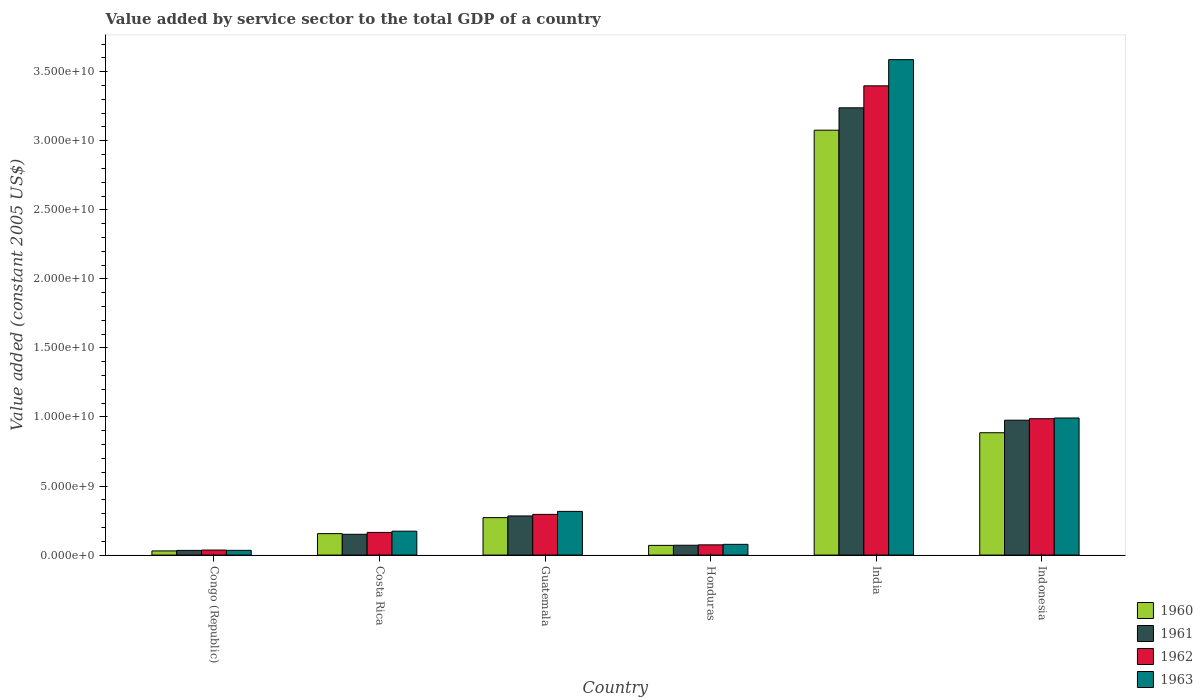How many groups of bars are there?
Offer a very short reply. 6. Are the number of bars per tick equal to the number of legend labels?
Ensure brevity in your answer.  Yes. Are the number of bars on each tick of the X-axis equal?
Your answer should be very brief. Yes. How many bars are there on the 4th tick from the right?
Offer a very short reply. 4. In how many cases, is the number of bars for a given country not equal to the number of legend labels?
Provide a succinct answer. 0. What is the value added by service sector in 1961 in Congo (Republic)?
Offer a very short reply. 3.39e+08. Across all countries, what is the maximum value added by service sector in 1960?
Ensure brevity in your answer.  3.08e+1. Across all countries, what is the minimum value added by service sector in 1963?
Your answer should be very brief. 3.42e+08. In which country was the value added by service sector in 1963 minimum?
Make the answer very short. Congo (Republic). What is the total value added by service sector in 1961 in the graph?
Provide a succinct answer. 4.75e+1. What is the difference between the value added by service sector in 1963 in Guatemala and that in Honduras?
Provide a succinct answer. 2.39e+09. What is the difference between the value added by service sector in 1961 in Honduras and the value added by service sector in 1962 in India?
Provide a succinct answer. -3.33e+1. What is the average value added by service sector in 1963 per country?
Provide a succinct answer. 8.64e+09. What is the difference between the value added by service sector of/in 1960 and value added by service sector of/in 1963 in Indonesia?
Your response must be concise. -1.07e+09. In how many countries, is the value added by service sector in 1963 greater than 9000000000 US$?
Your answer should be very brief. 2. What is the ratio of the value added by service sector in 1962 in Honduras to that in Indonesia?
Offer a very short reply. 0.07. Is the value added by service sector in 1961 in Costa Rica less than that in Indonesia?
Provide a succinct answer. Yes. What is the difference between the highest and the second highest value added by service sector in 1961?
Your response must be concise. 2.26e+1. What is the difference between the highest and the lowest value added by service sector in 1962?
Make the answer very short. 3.36e+1. In how many countries, is the value added by service sector in 1960 greater than the average value added by service sector in 1960 taken over all countries?
Make the answer very short. 2. Is the sum of the value added by service sector in 1963 in Congo (Republic) and Honduras greater than the maximum value added by service sector in 1961 across all countries?
Offer a terse response. No. Is it the case that in every country, the sum of the value added by service sector in 1963 and value added by service sector in 1961 is greater than the sum of value added by service sector in 1962 and value added by service sector in 1960?
Offer a terse response. No. How many bars are there?
Offer a very short reply. 24. How many countries are there in the graph?
Provide a short and direct response. 6. Does the graph contain any zero values?
Ensure brevity in your answer.  No. Where does the legend appear in the graph?
Provide a short and direct response. Bottom right. How are the legend labels stacked?
Your answer should be very brief. Vertical. What is the title of the graph?
Give a very brief answer. Value added by service sector to the total GDP of a country. Does "2002" appear as one of the legend labels in the graph?
Your answer should be very brief. No. What is the label or title of the Y-axis?
Provide a succinct answer. Value added (constant 2005 US$). What is the Value added (constant 2005 US$) in 1960 in Congo (Republic)?
Your answer should be very brief. 3.02e+08. What is the Value added (constant 2005 US$) of 1961 in Congo (Republic)?
Keep it short and to the point. 3.39e+08. What is the Value added (constant 2005 US$) in 1962 in Congo (Republic)?
Give a very brief answer. 3.64e+08. What is the Value added (constant 2005 US$) of 1963 in Congo (Republic)?
Provide a succinct answer. 3.42e+08. What is the Value added (constant 2005 US$) in 1960 in Costa Rica?
Offer a very short reply. 1.55e+09. What is the Value added (constant 2005 US$) of 1961 in Costa Rica?
Provide a short and direct response. 1.51e+09. What is the Value added (constant 2005 US$) in 1962 in Costa Rica?
Provide a succinct answer. 1.64e+09. What is the Value added (constant 2005 US$) of 1963 in Costa Rica?
Offer a very short reply. 1.73e+09. What is the Value added (constant 2005 US$) in 1960 in Guatemala?
Make the answer very short. 2.71e+09. What is the Value added (constant 2005 US$) of 1961 in Guatemala?
Ensure brevity in your answer.  2.83e+09. What is the Value added (constant 2005 US$) of 1962 in Guatemala?
Give a very brief answer. 2.95e+09. What is the Value added (constant 2005 US$) in 1963 in Guatemala?
Make the answer very short. 3.16e+09. What is the Value added (constant 2005 US$) in 1960 in Honduras?
Provide a short and direct response. 7.01e+08. What is the Value added (constant 2005 US$) of 1961 in Honduras?
Keep it short and to the point. 7.12e+08. What is the Value added (constant 2005 US$) of 1962 in Honduras?
Ensure brevity in your answer.  7.41e+08. What is the Value added (constant 2005 US$) of 1963 in Honduras?
Your answer should be compact. 7.78e+08. What is the Value added (constant 2005 US$) in 1960 in India?
Offer a very short reply. 3.08e+1. What is the Value added (constant 2005 US$) of 1961 in India?
Offer a very short reply. 3.24e+1. What is the Value added (constant 2005 US$) in 1962 in India?
Provide a succinct answer. 3.40e+1. What is the Value added (constant 2005 US$) in 1963 in India?
Offer a terse response. 3.59e+1. What is the Value added (constant 2005 US$) of 1960 in Indonesia?
Offer a very short reply. 8.86e+09. What is the Value added (constant 2005 US$) in 1961 in Indonesia?
Your answer should be very brief. 9.77e+09. What is the Value added (constant 2005 US$) in 1962 in Indonesia?
Ensure brevity in your answer.  9.88e+09. What is the Value added (constant 2005 US$) in 1963 in Indonesia?
Provide a short and direct response. 9.93e+09. Across all countries, what is the maximum Value added (constant 2005 US$) of 1960?
Offer a very short reply. 3.08e+1. Across all countries, what is the maximum Value added (constant 2005 US$) of 1961?
Make the answer very short. 3.24e+1. Across all countries, what is the maximum Value added (constant 2005 US$) of 1962?
Give a very brief answer. 3.40e+1. Across all countries, what is the maximum Value added (constant 2005 US$) of 1963?
Ensure brevity in your answer.  3.59e+1. Across all countries, what is the minimum Value added (constant 2005 US$) in 1960?
Give a very brief answer. 3.02e+08. Across all countries, what is the minimum Value added (constant 2005 US$) in 1961?
Provide a succinct answer. 3.39e+08. Across all countries, what is the minimum Value added (constant 2005 US$) in 1962?
Provide a short and direct response. 3.64e+08. Across all countries, what is the minimum Value added (constant 2005 US$) of 1963?
Ensure brevity in your answer.  3.42e+08. What is the total Value added (constant 2005 US$) of 1960 in the graph?
Your answer should be compact. 4.49e+1. What is the total Value added (constant 2005 US$) in 1961 in the graph?
Offer a terse response. 4.75e+1. What is the total Value added (constant 2005 US$) in 1962 in the graph?
Provide a short and direct response. 4.95e+1. What is the total Value added (constant 2005 US$) of 1963 in the graph?
Your response must be concise. 5.18e+1. What is the difference between the Value added (constant 2005 US$) of 1960 in Congo (Republic) and that in Costa Rica?
Offer a very short reply. -1.25e+09. What is the difference between the Value added (constant 2005 US$) in 1961 in Congo (Republic) and that in Costa Rica?
Give a very brief answer. -1.17e+09. What is the difference between the Value added (constant 2005 US$) of 1962 in Congo (Republic) and that in Costa Rica?
Give a very brief answer. -1.28e+09. What is the difference between the Value added (constant 2005 US$) of 1963 in Congo (Republic) and that in Costa Rica?
Ensure brevity in your answer.  -1.39e+09. What is the difference between the Value added (constant 2005 US$) in 1960 in Congo (Republic) and that in Guatemala?
Ensure brevity in your answer.  -2.41e+09. What is the difference between the Value added (constant 2005 US$) of 1961 in Congo (Republic) and that in Guatemala?
Provide a succinct answer. -2.49e+09. What is the difference between the Value added (constant 2005 US$) in 1962 in Congo (Republic) and that in Guatemala?
Your response must be concise. -2.58e+09. What is the difference between the Value added (constant 2005 US$) in 1963 in Congo (Republic) and that in Guatemala?
Offer a terse response. -2.82e+09. What is the difference between the Value added (constant 2005 US$) of 1960 in Congo (Republic) and that in Honduras?
Give a very brief answer. -4.00e+08. What is the difference between the Value added (constant 2005 US$) of 1961 in Congo (Republic) and that in Honduras?
Your response must be concise. -3.73e+08. What is the difference between the Value added (constant 2005 US$) in 1962 in Congo (Republic) and that in Honduras?
Give a very brief answer. -3.77e+08. What is the difference between the Value added (constant 2005 US$) in 1963 in Congo (Republic) and that in Honduras?
Keep it short and to the point. -4.36e+08. What is the difference between the Value added (constant 2005 US$) in 1960 in Congo (Republic) and that in India?
Provide a succinct answer. -3.05e+1. What is the difference between the Value added (constant 2005 US$) of 1961 in Congo (Republic) and that in India?
Keep it short and to the point. -3.21e+1. What is the difference between the Value added (constant 2005 US$) of 1962 in Congo (Republic) and that in India?
Keep it short and to the point. -3.36e+1. What is the difference between the Value added (constant 2005 US$) of 1963 in Congo (Republic) and that in India?
Offer a very short reply. -3.55e+1. What is the difference between the Value added (constant 2005 US$) in 1960 in Congo (Republic) and that in Indonesia?
Ensure brevity in your answer.  -8.56e+09. What is the difference between the Value added (constant 2005 US$) of 1961 in Congo (Republic) and that in Indonesia?
Give a very brief answer. -9.43e+09. What is the difference between the Value added (constant 2005 US$) of 1962 in Congo (Republic) and that in Indonesia?
Keep it short and to the point. -9.51e+09. What is the difference between the Value added (constant 2005 US$) in 1963 in Congo (Republic) and that in Indonesia?
Make the answer very short. -9.58e+09. What is the difference between the Value added (constant 2005 US$) of 1960 in Costa Rica and that in Guatemala?
Keep it short and to the point. -1.16e+09. What is the difference between the Value added (constant 2005 US$) of 1961 in Costa Rica and that in Guatemala?
Provide a succinct answer. -1.33e+09. What is the difference between the Value added (constant 2005 US$) of 1962 in Costa Rica and that in Guatemala?
Keep it short and to the point. -1.31e+09. What is the difference between the Value added (constant 2005 US$) of 1963 in Costa Rica and that in Guatemala?
Offer a very short reply. -1.43e+09. What is the difference between the Value added (constant 2005 US$) of 1960 in Costa Rica and that in Honduras?
Provide a succinct answer. 8.51e+08. What is the difference between the Value added (constant 2005 US$) of 1961 in Costa Rica and that in Honduras?
Keep it short and to the point. 7.94e+08. What is the difference between the Value added (constant 2005 US$) of 1962 in Costa Rica and that in Honduras?
Your response must be concise. 9.01e+08. What is the difference between the Value added (constant 2005 US$) of 1963 in Costa Rica and that in Honduras?
Your answer should be very brief. 9.53e+08. What is the difference between the Value added (constant 2005 US$) of 1960 in Costa Rica and that in India?
Give a very brief answer. -2.92e+1. What is the difference between the Value added (constant 2005 US$) of 1961 in Costa Rica and that in India?
Offer a terse response. -3.09e+1. What is the difference between the Value added (constant 2005 US$) in 1962 in Costa Rica and that in India?
Offer a very short reply. -3.23e+1. What is the difference between the Value added (constant 2005 US$) of 1963 in Costa Rica and that in India?
Make the answer very short. -3.41e+1. What is the difference between the Value added (constant 2005 US$) of 1960 in Costa Rica and that in Indonesia?
Offer a terse response. -7.31e+09. What is the difference between the Value added (constant 2005 US$) of 1961 in Costa Rica and that in Indonesia?
Your response must be concise. -8.26e+09. What is the difference between the Value added (constant 2005 US$) of 1962 in Costa Rica and that in Indonesia?
Keep it short and to the point. -8.23e+09. What is the difference between the Value added (constant 2005 US$) of 1963 in Costa Rica and that in Indonesia?
Your answer should be compact. -8.20e+09. What is the difference between the Value added (constant 2005 US$) of 1960 in Guatemala and that in Honduras?
Make the answer very short. 2.01e+09. What is the difference between the Value added (constant 2005 US$) in 1961 in Guatemala and that in Honduras?
Provide a succinct answer. 2.12e+09. What is the difference between the Value added (constant 2005 US$) in 1962 in Guatemala and that in Honduras?
Offer a terse response. 2.21e+09. What is the difference between the Value added (constant 2005 US$) of 1963 in Guatemala and that in Honduras?
Give a very brief answer. 2.39e+09. What is the difference between the Value added (constant 2005 US$) of 1960 in Guatemala and that in India?
Your answer should be compact. -2.81e+1. What is the difference between the Value added (constant 2005 US$) of 1961 in Guatemala and that in India?
Your answer should be compact. -2.96e+1. What is the difference between the Value added (constant 2005 US$) of 1962 in Guatemala and that in India?
Make the answer very short. -3.10e+1. What is the difference between the Value added (constant 2005 US$) of 1963 in Guatemala and that in India?
Offer a very short reply. -3.27e+1. What is the difference between the Value added (constant 2005 US$) in 1960 in Guatemala and that in Indonesia?
Keep it short and to the point. -6.15e+09. What is the difference between the Value added (constant 2005 US$) of 1961 in Guatemala and that in Indonesia?
Your response must be concise. -6.93e+09. What is the difference between the Value added (constant 2005 US$) of 1962 in Guatemala and that in Indonesia?
Ensure brevity in your answer.  -6.93e+09. What is the difference between the Value added (constant 2005 US$) of 1963 in Guatemala and that in Indonesia?
Provide a succinct answer. -6.76e+09. What is the difference between the Value added (constant 2005 US$) in 1960 in Honduras and that in India?
Your answer should be compact. -3.01e+1. What is the difference between the Value added (constant 2005 US$) in 1961 in Honduras and that in India?
Keep it short and to the point. -3.17e+1. What is the difference between the Value added (constant 2005 US$) in 1962 in Honduras and that in India?
Offer a very short reply. -3.32e+1. What is the difference between the Value added (constant 2005 US$) in 1963 in Honduras and that in India?
Offer a terse response. -3.51e+1. What is the difference between the Value added (constant 2005 US$) in 1960 in Honduras and that in Indonesia?
Keep it short and to the point. -8.16e+09. What is the difference between the Value added (constant 2005 US$) in 1961 in Honduras and that in Indonesia?
Make the answer very short. -9.05e+09. What is the difference between the Value added (constant 2005 US$) of 1962 in Honduras and that in Indonesia?
Ensure brevity in your answer.  -9.13e+09. What is the difference between the Value added (constant 2005 US$) of 1963 in Honduras and that in Indonesia?
Your response must be concise. -9.15e+09. What is the difference between the Value added (constant 2005 US$) of 1960 in India and that in Indonesia?
Ensure brevity in your answer.  2.19e+1. What is the difference between the Value added (constant 2005 US$) in 1961 in India and that in Indonesia?
Offer a very short reply. 2.26e+1. What is the difference between the Value added (constant 2005 US$) of 1962 in India and that in Indonesia?
Your answer should be very brief. 2.41e+1. What is the difference between the Value added (constant 2005 US$) in 1963 in India and that in Indonesia?
Ensure brevity in your answer.  2.60e+1. What is the difference between the Value added (constant 2005 US$) in 1960 in Congo (Republic) and the Value added (constant 2005 US$) in 1961 in Costa Rica?
Your answer should be very brief. -1.20e+09. What is the difference between the Value added (constant 2005 US$) of 1960 in Congo (Republic) and the Value added (constant 2005 US$) of 1962 in Costa Rica?
Offer a very short reply. -1.34e+09. What is the difference between the Value added (constant 2005 US$) of 1960 in Congo (Republic) and the Value added (constant 2005 US$) of 1963 in Costa Rica?
Make the answer very short. -1.43e+09. What is the difference between the Value added (constant 2005 US$) in 1961 in Congo (Republic) and the Value added (constant 2005 US$) in 1962 in Costa Rica?
Keep it short and to the point. -1.30e+09. What is the difference between the Value added (constant 2005 US$) in 1961 in Congo (Republic) and the Value added (constant 2005 US$) in 1963 in Costa Rica?
Make the answer very short. -1.39e+09. What is the difference between the Value added (constant 2005 US$) in 1962 in Congo (Republic) and the Value added (constant 2005 US$) in 1963 in Costa Rica?
Your answer should be very brief. -1.37e+09. What is the difference between the Value added (constant 2005 US$) in 1960 in Congo (Republic) and the Value added (constant 2005 US$) in 1961 in Guatemala?
Your response must be concise. -2.53e+09. What is the difference between the Value added (constant 2005 US$) of 1960 in Congo (Republic) and the Value added (constant 2005 US$) of 1962 in Guatemala?
Your answer should be very brief. -2.65e+09. What is the difference between the Value added (constant 2005 US$) in 1960 in Congo (Republic) and the Value added (constant 2005 US$) in 1963 in Guatemala?
Keep it short and to the point. -2.86e+09. What is the difference between the Value added (constant 2005 US$) in 1961 in Congo (Republic) and the Value added (constant 2005 US$) in 1962 in Guatemala?
Offer a terse response. -2.61e+09. What is the difference between the Value added (constant 2005 US$) in 1961 in Congo (Republic) and the Value added (constant 2005 US$) in 1963 in Guatemala?
Offer a terse response. -2.83e+09. What is the difference between the Value added (constant 2005 US$) of 1962 in Congo (Republic) and the Value added (constant 2005 US$) of 1963 in Guatemala?
Offer a terse response. -2.80e+09. What is the difference between the Value added (constant 2005 US$) in 1960 in Congo (Republic) and the Value added (constant 2005 US$) in 1961 in Honduras?
Your answer should be very brief. -4.10e+08. What is the difference between the Value added (constant 2005 US$) of 1960 in Congo (Republic) and the Value added (constant 2005 US$) of 1962 in Honduras?
Your response must be concise. -4.39e+08. What is the difference between the Value added (constant 2005 US$) of 1960 in Congo (Republic) and the Value added (constant 2005 US$) of 1963 in Honduras?
Give a very brief answer. -4.76e+08. What is the difference between the Value added (constant 2005 US$) of 1961 in Congo (Republic) and the Value added (constant 2005 US$) of 1962 in Honduras?
Your answer should be compact. -4.02e+08. What is the difference between the Value added (constant 2005 US$) in 1961 in Congo (Republic) and the Value added (constant 2005 US$) in 1963 in Honduras?
Your response must be concise. -4.39e+08. What is the difference between the Value added (constant 2005 US$) of 1962 in Congo (Republic) and the Value added (constant 2005 US$) of 1963 in Honduras?
Keep it short and to the point. -4.14e+08. What is the difference between the Value added (constant 2005 US$) in 1960 in Congo (Republic) and the Value added (constant 2005 US$) in 1961 in India?
Keep it short and to the point. -3.21e+1. What is the difference between the Value added (constant 2005 US$) in 1960 in Congo (Republic) and the Value added (constant 2005 US$) in 1962 in India?
Provide a short and direct response. -3.37e+1. What is the difference between the Value added (constant 2005 US$) in 1960 in Congo (Republic) and the Value added (constant 2005 US$) in 1963 in India?
Keep it short and to the point. -3.56e+1. What is the difference between the Value added (constant 2005 US$) in 1961 in Congo (Republic) and the Value added (constant 2005 US$) in 1962 in India?
Give a very brief answer. -3.36e+1. What is the difference between the Value added (constant 2005 US$) of 1961 in Congo (Republic) and the Value added (constant 2005 US$) of 1963 in India?
Give a very brief answer. -3.55e+1. What is the difference between the Value added (constant 2005 US$) in 1962 in Congo (Republic) and the Value added (constant 2005 US$) in 1963 in India?
Give a very brief answer. -3.55e+1. What is the difference between the Value added (constant 2005 US$) of 1960 in Congo (Republic) and the Value added (constant 2005 US$) of 1961 in Indonesia?
Provide a succinct answer. -9.46e+09. What is the difference between the Value added (constant 2005 US$) in 1960 in Congo (Republic) and the Value added (constant 2005 US$) in 1962 in Indonesia?
Offer a very short reply. -9.57e+09. What is the difference between the Value added (constant 2005 US$) of 1960 in Congo (Republic) and the Value added (constant 2005 US$) of 1963 in Indonesia?
Your answer should be compact. -9.63e+09. What is the difference between the Value added (constant 2005 US$) in 1961 in Congo (Republic) and the Value added (constant 2005 US$) in 1962 in Indonesia?
Your answer should be very brief. -9.54e+09. What is the difference between the Value added (constant 2005 US$) in 1961 in Congo (Republic) and the Value added (constant 2005 US$) in 1963 in Indonesia?
Provide a succinct answer. -9.59e+09. What is the difference between the Value added (constant 2005 US$) of 1962 in Congo (Republic) and the Value added (constant 2005 US$) of 1963 in Indonesia?
Make the answer very short. -9.56e+09. What is the difference between the Value added (constant 2005 US$) in 1960 in Costa Rica and the Value added (constant 2005 US$) in 1961 in Guatemala?
Make the answer very short. -1.28e+09. What is the difference between the Value added (constant 2005 US$) of 1960 in Costa Rica and the Value added (constant 2005 US$) of 1962 in Guatemala?
Offer a terse response. -1.39e+09. What is the difference between the Value added (constant 2005 US$) of 1960 in Costa Rica and the Value added (constant 2005 US$) of 1963 in Guatemala?
Provide a succinct answer. -1.61e+09. What is the difference between the Value added (constant 2005 US$) in 1961 in Costa Rica and the Value added (constant 2005 US$) in 1962 in Guatemala?
Provide a succinct answer. -1.44e+09. What is the difference between the Value added (constant 2005 US$) of 1961 in Costa Rica and the Value added (constant 2005 US$) of 1963 in Guatemala?
Your answer should be compact. -1.66e+09. What is the difference between the Value added (constant 2005 US$) of 1962 in Costa Rica and the Value added (constant 2005 US$) of 1963 in Guatemala?
Offer a terse response. -1.52e+09. What is the difference between the Value added (constant 2005 US$) of 1960 in Costa Rica and the Value added (constant 2005 US$) of 1961 in Honduras?
Your answer should be very brief. 8.41e+08. What is the difference between the Value added (constant 2005 US$) of 1960 in Costa Rica and the Value added (constant 2005 US$) of 1962 in Honduras?
Your response must be concise. 8.12e+08. What is the difference between the Value added (constant 2005 US$) in 1960 in Costa Rica and the Value added (constant 2005 US$) in 1963 in Honduras?
Your response must be concise. 7.75e+08. What is the difference between the Value added (constant 2005 US$) in 1961 in Costa Rica and the Value added (constant 2005 US$) in 1962 in Honduras?
Make the answer very short. 7.65e+08. What is the difference between the Value added (constant 2005 US$) of 1961 in Costa Rica and the Value added (constant 2005 US$) of 1963 in Honduras?
Offer a terse response. 7.28e+08. What is the difference between the Value added (constant 2005 US$) of 1962 in Costa Rica and the Value added (constant 2005 US$) of 1963 in Honduras?
Offer a very short reply. 8.63e+08. What is the difference between the Value added (constant 2005 US$) of 1960 in Costa Rica and the Value added (constant 2005 US$) of 1961 in India?
Your response must be concise. -3.08e+1. What is the difference between the Value added (constant 2005 US$) of 1960 in Costa Rica and the Value added (constant 2005 US$) of 1962 in India?
Provide a succinct answer. -3.24e+1. What is the difference between the Value added (constant 2005 US$) in 1960 in Costa Rica and the Value added (constant 2005 US$) in 1963 in India?
Your answer should be very brief. -3.43e+1. What is the difference between the Value added (constant 2005 US$) in 1961 in Costa Rica and the Value added (constant 2005 US$) in 1962 in India?
Provide a succinct answer. -3.25e+1. What is the difference between the Value added (constant 2005 US$) of 1961 in Costa Rica and the Value added (constant 2005 US$) of 1963 in India?
Give a very brief answer. -3.44e+1. What is the difference between the Value added (constant 2005 US$) in 1962 in Costa Rica and the Value added (constant 2005 US$) in 1963 in India?
Ensure brevity in your answer.  -3.42e+1. What is the difference between the Value added (constant 2005 US$) of 1960 in Costa Rica and the Value added (constant 2005 US$) of 1961 in Indonesia?
Keep it short and to the point. -8.21e+09. What is the difference between the Value added (constant 2005 US$) of 1960 in Costa Rica and the Value added (constant 2005 US$) of 1962 in Indonesia?
Provide a short and direct response. -8.32e+09. What is the difference between the Value added (constant 2005 US$) in 1960 in Costa Rica and the Value added (constant 2005 US$) in 1963 in Indonesia?
Offer a very short reply. -8.37e+09. What is the difference between the Value added (constant 2005 US$) of 1961 in Costa Rica and the Value added (constant 2005 US$) of 1962 in Indonesia?
Keep it short and to the point. -8.37e+09. What is the difference between the Value added (constant 2005 US$) in 1961 in Costa Rica and the Value added (constant 2005 US$) in 1963 in Indonesia?
Your answer should be compact. -8.42e+09. What is the difference between the Value added (constant 2005 US$) of 1962 in Costa Rica and the Value added (constant 2005 US$) of 1963 in Indonesia?
Provide a short and direct response. -8.29e+09. What is the difference between the Value added (constant 2005 US$) of 1960 in Guatemala and the Value added (constant 2005 US$) of 1961 in Honduras?
Give a very brief answer. 2.00e+09. What is the difference between the Value added (constant 2005 US$) of 1960 in Guatemala and the Value added (constant 2005 US$) of 1962 in Honduras?
Your response must be concise. 1.97e+09. What is the difference between the Value added (constant 2005 US$) in 1960 in Guatemala and the Value added (constant 2005 US$) in 1963 in Honduras?
Give a very brief answer. 1.93e+09. What is the difference between the Value added (constant 2005 US$) of 1961 in Guatemala and the Value added (constant 2005 US$) of 1962 in Honduras?
Your answer should be very brief. 2.09e+09. What is the difference between the Value added (constant 2005 US$) of 1961 in Guatemala and the Value added (constant 2005 US$) of 1963 in Honduras?
Keep it short and to the point. 2.06e+09. What is the difference between the Value added (constant 2005 US$) of 1962 in Guatemala and the Value added (constant 2005 US$) of 1963 in Honduras?
Your response must be concise. 2.17e+09. What is the difference between the Value added (constant 2005 US$) of 1960 in Guatemala and the Value added (constant 2005 US$) of 1961 in India?
Ensure brevity in your answer.  -2.97e+1. What is the difference between the Value added (constant 2005 US$) of 1960 in Guatemala and the Value added (constant 2005 US$) of 1962 in India?
Give a very brief answer. -3.13e+1. What is the difference between the Value added (constant 2005 US$) of 1960 in Guatemala and the Value added (constant 2005 US$) of 1963 in India?
Offer a terse response. -3.32e+1. What is the difference between the Value added (constant 2005 US$) in 1961 in Guatemala and the Value added (constant 2005 US$) in 1962 in India?
Provide a succinct answer. -3.11e+1. What is the difference between the Value added (constant 2005 US$) of 1961 in Guatemala and the Value added (constant 2005 US$) of 1963 in India?
Ensure brevity in your answer.  -3.30e+1. What is the difference between the Value added (constant 2005 US$) in 1962 in Guatemala and the Value added (constant 2005 US$) in 1963 in India?
Your answer should be compact. -3.29e+1. What is the difference between the Value added (constant 2005 US$) in 1960 in Guatemala and the Value added (constant 2005 US$) in 1961 in Indonesia?
Give a very brief answer. -7.05e+09. What is the difference between the Value added (constant 2005 US$) in 1960 in Guatemala and the Value added (constant 2005 US$) in 1962 in Indonesia?
Offer a terse response. -7.16e+09. What is the difference between the Value added (constant 2005 US$) in 1960 in Guatemala and the Value added (constant 2005 US$) in 1963 in Indonesia?
Provide a succinct answer. -7.21e+09. What is the difference between the Value added (constant 2005 US$) of 1961 in Guatemala and the Value added (constant 2005 US$) of 1962 in Indonesia?
Offer a terse response. -7.04e+09. What is the difference between the Value added (constant 2005 US$) of 1961 in Guatemala and the Value added (constant 2005 US$) of 1963 in Indonesia?
Your response must be concise. -7.09e+09. What is the difference between the Value added (constant 2005 US$) of 1962 in Guatemala and the Value added (constant 2005 US$) of 1963 in Indonesia?
Your answer should be very brief. -6.98e+09. What is the difference between the Value added (constant 2005 US$) in 1960 in Honduras and the Value added (constant 2005 US$) in 1961 in India?
Provide a short and direct response. -3.17e+1. What is the difference between the Value added (constant 2005 US$) of 1960 in Honduras and the Value added (constant 2005 US$) of 1962 in India?
Your answer should be very brief. -3.33e+1. What is the difference between the Value added (constant 2005 US$) in 1960 in Honduras and the Value added (constant 2005 US$) in 1963 in India?
Your answer should be very brief. -3.52e+1. What is the difference between the Value added (constant 2005 US$) in 1961 in Honduras and the Value added (constant 2005 US$) in 1962 in India?
Provide a succinct answer. -3.33e+1. What is the difference between the Value added (constant 2005 US$) of 1961 in Honduras and the Value added (constant 2005 US$) of 1963 in India?
Your response must be concise. -3.52e+1. What is the difference between the Value added (constant 2005 US$) in 1962 in Honduras and the Value added (constant 2005 US$) in 1963 in India?
Offer a terse response. -3.51e+1. What is the difference between the Value added (constant 2005 US$) in 1960 in Honduras and the Value added (constant 2005 US$) in 1961 in Indonesia?
Give a very brief answer. -9.07e+09. What is the difference between the Value added (constant 2005 US$) of 1960 in Honduras and the Value added (constant 2005 US$) of 1962 in Indonesia?
Provide a succinct answer. -9.17e+09. What is the difference between the Value added (constant 2005 US$) in 1960 in Honduras and the Value added (constant 2005 US$) in 1963 in Indonesia?
Keep it short and to the point. -9.23e+09. What is the difference between the Value added (constant 2005 US$) in 1961 in Honduras and the Value added (constant 2005 US$) in 1962 in Indonesia?
Keep it short and to the point. -9.16e+09. What is the difference between the Value added (constant 2005 US$) of 1961 in Honduras and the Value added (constant 2005 US$) of 1963 in Indonesia?
Give a very brief answer. -9.22e+09. What is the difference between the Value added (constant 2005 US$) of 1962 in Honduras and the Value added (constant 2005 US$) of 1963 in Indonesia?
Your answer should be very brief. -9.19e+09. What is the difference between the Value added (constant 2005 US$) in 1960 in India and the Value added (constant 2005 US$) in 1961 in Indonesia?
Keep it short and to the point. 2.10e+1. What is the difference between the Value added (constant 2005 US$) in 1960 in India and the Value added (constant 2005 US$) in 1962 in Indonesia?
Ensure brevity in your answer.  2.09e+1. What is the difference between the Value added (constant 2005 US$) of 1960 in India and the Value added (constant 2005 US$) of 1963 in Indonesia?
Make the answer very short. 2.08e+1. What is the difference between the Value added (constant 2005 US$) in 1961 in India and the Value added (constant 2005 US$) in 1962 in Indonesia?
Your response must be concise. 2.25e+1. What is the difference between the Value added (constant 2005 US$) in 1961 in India and the Value added (constant 2005 US$) in 1963 in Indonesia?
Give a very brief answer. 2.25e+1. What is the difference between the Value added (constant 2005 US$) in 1962 in India and the Value added (constant 2005 US$) in 1963 in Indonesia?
Provide a short and direct response. 2.41e+1. What is the average Value added (constant 2005 US$) in 1960 per country?
Your response must be concise. 7.48e+09. What is the average Value added (constant 2005 US$) in 1961 per country?
Your answer should be very brief. 7.92e+09. What is the average Value added (constant 2005 US$) of 1962 per country?
Make the answer very short. 8.26e+09. What is the average Value added (constant 2005 US$) of 1963 per country?
Your answer should be very brief. 8.64e+09. What is the difference between the Value added (constant 2005 US$) in 1960 and Value added (constant 2005 US$) in 1961 in Congo (Republic)?
Provide a succinct answer. -3.74e+07. What is the difference between the Value added (constant 2005 US$) of 1960 and Value added (constant 2005 US$) of 1962 in Congo (Republic)?
Your answer should be very brief. -6.23e+07. What is the difference between the Value added (constant 2005 US$) of 1960 and Value added (constant 2005 US$) of 1963 in Congo (Republic)?
Make the answer very short. -4.05e+07. What is the difference between the Value added (constant 2005 US$) of 1961 and Value added (constant 2005 US$) of 1962 in Congo (Republic)?
Your answer should be compact. -2.49e+07. What is the difference between the Value added (constant 2005 US$) in 1961 and Value added (constant 2005 US$) in 1963 in Congo (Republic)?
Offer a terse response. -3.09e+06. What is the difference between the Value added (constant 2005 US$) in 1962 and Value added (constant 2005 US$) in 1963 in Congo (Republic)?
Provide a short and direct response. 2.18e+07. What is the difference between the Value added (constant 2005 US$) in 1960 and Value added (constant 2005 US$) in 1961 in Costa Rica?
Ensure brevity in your answer.  4.72e+07. What is the difference between the Value added (constant 2005 US$) of 1960 and Value added (constant 2005 US$) of 1962 in Costa Rica?
Your answer should be compact. -8.87e+07. What is the difference between the Value added (constant 2005 US$) of 1960 and Value added (constant 2005 US$) of 1963 in Costa Rica?
Ensure brevity in your answer.  -1.78e+08. What is the difference between the Value added (constant 2005 US$) in 1961 and Value added (constant 2005 US$) in 1962 in Costa Rica?
Provide a short and direct response. -1.36e+08. What is the difference between the Value added (constant 2005 US$) of 1961 and Value added (constant 2005 US$) of 1963 in Costa Rica?
Provide a succinct answer. -2.25e+08. What is the difference between the Value added (constant 2005 US$) in 1962 and Value added (constant 2005 US$) in 1963 in Costa Rica?
Provide a succinct answer. -8.94e+07. What is the difference between the Value added (constant 2005 US$) in 1960 and Value added (constant 2005 US$) in 1961 in Guatemala?
Your answer should be compact. -1.22e+08. What is the difference between the Value added (constant 2005 US$) of 1960 and Value added (constant 2005 US$) of 1962 in Guatemala?
Make the answer very short. -2.35e+08. What is the difference between the Value added (constant 2005 US$) in 1960 and Value added (constant 2005 US$) in 1963 in Guatemala?
Your response must be concise. -4.53e+08. What is the difference between the Value added (constant 2005 US$) in 1961 and Value added (constant 2005 US$) in 1962 in Guatemala?
Ensure brevity in your answer.  -1.14e+08. What is the difference between the Value added (constant 2005 US$) of 1961 and Value added (constant 2005 US$) of 1963 in Guatemala?
Your answer should be very brief. -3.31e+08. What is the difference between the Value added (constant 2005 US$) of 1962 and Value added (constant 2005 US$) of 1963 in Guatemala?
Your response must be concise. -2.17e+08. What is the difference between the Value added (constant 2005 US$) of 1960 and Value added (constant 2005 US$) of 1961 in Honduras?
Ensure brevity in your answer.  -1.04e+07. What is the difference between the Value added (constant 2005 US$) of 1960 and Value added (constant 2005 US$) of 1962 in Honduras?
Your answer should be compact. -3.93e+07. What is the difference between the Value added (constant 2005 US$) of 1960 and Value added (constant 2005 US$) of 1963 in Honduras?
Your answer should be very brief. -7.65e+07. What is the difference between the Value added (constant 2005 US$) in 1961 and Value added (constant 2005 US$) in 1962 in Honduras?
Give a very brief answer. -2.89e+07. What is the difference between the Value added (constant 2005 US$) in 1961 and Value added (constant 2005 US$) in 1963 in Honduras?
Make the answer very short. -6.62e+07. What is the difference between the Value added (constant 2005 US$) of 1962 and Value added (constant 2005 US$) of 1963 in Honduras?
Offer a terse response. -3.72e+07. What is the difference between the Value added (constant 2005 US$) of 1960 and Value added (constant 2005 US$) of 1961 in India?
Your response must be concise. -1.62e+09. What is the difference between the Value added (constant 2005 US$) in 1960 and Value added (constant 2005 US$) in 1962 in India?
Your answer should be compact. -3.21e+09. What is the difference between the Value added (constant 2005 US$) of 1960 and Value added (constant 2005 US$) of 1963 in India?
Your answer should be very brief. -5.11e+09. What is the difference between the Value added (constant 2005 US$) of 1961 and Value added (constant 2005 US$) of 1962 in India?
Give a very brief answer. -1.59e+09. What is the difference between the Value added (constant 2005 US$) in 1961 and Value added (constant 2005 US$) in 1963 in India?
Offer a terse response. -3.49e+09. What is the difference between the Value added (constant 2005 US$) of 1962 and Value added (constant 2005 US$) of 1963 in India?
Provide a succinct answer. -1.90e+09. What is the difference between the Value added (constant 2005 US$) in 1960 and Value added (constant 2005 US$) in 1961 in Indonesia?
Your answer should be compact. -9.08e+08. What is the difference between the Value added (constant 2005 US$) in 1960 and Value added (constant 2005 US$) in 1962 in Indonesia?
Your answer should be compact. -1.02e+09. What is the difference between the Value added (constant 2005 US$) in 1960 and Value added (constant 2005 US$) in 1963 in Indonesia?
Make the answer very short. -1.07e+09. What is the difference between the Value added (constant 2005 US$) in 1961 and Value added (constant 2005 US$) in 1962 in Indonesia?
Offer a very short reply. -1.09e+08. What is the difference between the Value added (constant 2005 US$) in 1961 and Value added (constant 2005 US$) in 1963 in Indonesia?
Make the answer very short. -1.60e+08. What is the difference between the Value added (constant 2005 US$) of 1962 and Value added (constant 2005 US$) of 1963 in Indonesia?
Provide a succinct answer. -5.15e+07. What is the ratio of the Value added (constant 2005 US$) in 1960 in Congo (Republic) to that in Costa Rica?
Your answer should be very brief. 0.19. What is the ratio of the Value added (constant 2005 US$) of 1961 in Congo (Republic) to that in Costa Rica?
Keep it short and to the point. 0.23. What is the ratio of the Value added (constant 2005 US$) in 1962 in Congo (Republic) to that in Costa Rica?
Give a very brief answer. 0.22. What is the ratio of the Value added (constant 2005 US$) in 1963 in Congo (Republic) to that in Costa Rica?
Make the answer very short. 0.2. What is the ratio of the Value added (constant 2005 US$) of 1960 in Congo (Republic) to that in Guatemala?
Your answer should be compact. 0.11. What is the ratio of the Value added (constant 2005 US$) of 1961 in Congo (Republic) to that in Guatemala?
Your answer should be very brief. 0.12. What is the ratio of the Value added (constant 2005 US$) of 1962 in Congo (Republic) to that in Guatemala?
Your response must be concise. 0.12. What is the ratio of the Value added (constant 2005 US$) of 1963 in Congo (Republic) to that in Guatemala?
Your answer should be compact. 0.11. What is the ratio of the Value added (constant 2005 US$) in 1960 in Congo (Republic) to that in Honduras?
Your answer should be compact. 0.43. What is the ratio of the Value added (constant 2005 US$) in 1961 in Congo (Republic) to that in Honduras?
Provide a succinct answer. 0.48. What is the ratio of the Value added (constant 2005 US$) in 1962 in Congo (Republic) to that in Honduras?
Your answer should be compact. 0.49. What is the ratio of the Value added (constant 2005 US$) in 1963 in Congo (Republic) to that in Honduras?
Your answer should be compact. 0.44. What is the ratio of the Value added (constant 2005 US$) in 1960 in Congo (Republic) to that in India?
Offer a terse response. 0.01. What is the ratio of the Value added (constant 2005 US$) of 1961 in Congo (Republic) to that in India?
Provide a succinct answer. 0.01. What is the ratio of the Value added (constant 2005 US$) of 1962 in Congo (Republic) to that in India?
Offer a terse response. 0.01. What is the ratio of the Value added (constant 2005 US$) of 1963 in Congo (Republic) to that in India?
Give a very brief answer. 0.01. What is the ratio of the Value added (constant 2005 US$) in 1960 in Congo (Republic) to that in Indonesia?
Keep it short and to the point. 0.03. What is the ratio of the Value added (constant 2005 US$) of 1961 in Congo (Republic) to that in Indonesia?
Offer a terse response. 0.03. What is the ratio of the Value added (constant 2005 US$) of 1962 in Congo (Republic) to that in Indonesia?
Give a very brief answer. 0.04. What is the ratio of the Value added (constant 2005 US$) in 1963 in Congo (Republic) to that in Indonesia?
Give a very brief answer. 0.03. What is the ratio of the Value added (constant 2005 US$) of 1960 in Costa Rica to that in Guatemala?
Provide a short and direct response. 0.57. What is the ratio of the Value added (constant 2005 US$) of 1961 in Costa Rica to that in Guatemala?
Offer a terse response. 0.53. What is the ratio of the Value added (constant 2005 US$) of 1962 in Costa Rica to that in Guatemala?
Make the answer very short. 0.56. What is the ratio of the Value added (constant 2005 US$) of 1963 in Costa Rica to that in Guatemala?
Ensure brevity in your answer.  0.55. What is the ratio of the Value added (constant 2005 US$) in 1960 in Costa Rica to that in Honduras?
Provide a succinct answer. 2.21. What is the ratio of the Value added (constant 2005 US$) of 1961 in Costa Rica to that in Honduras?
Your answer should be compact. 2.12. What is the ratio of the Value added (constant 2005 US$) of 1962 in Costa Rica to that in Honduras?
Keep it short and to the point. 2.22. What is the ratio of the Value added (constant 2005 US$) in 1963 in Costa Rica to that in Honduras?
Your response must be concise. 2.23. What is the ratio of the Value added (constant 2005 US$) in 1960 in Costa Rica to that in India?
Your response must be concise. 0.05. What is the ratio of the Value added (constant 2005 US$) of 1961 in Costa Rica to that in India?
Your response must be concise. 0.05. What is the ratio of the Value added (constant 2005 US$) of 1962 in Costa Rica to that in India?
Offer a very short reply. 0.05. What is the ratio of the Value added (constant 2005 US$) of 1963 in Costa Rica to that in India?
Give a very brief answer. 0.05. What is the ratio of the Value added (constant 2005 US$) in 1960 in Costa Rica to that in Indonesia?
Your response must be concise. 0.18. What is the ratio of the Value added (constant 2005 US$) in 1961 in Costa Rica to that in Indonesia?
Ensure brevity in your answer.  0.15. What is the ratio of the Value added (constant 2005 US$) in 1962 in Costa Rica to that in Indonesia?
Keep it short and to the point. 0.17. What is the ratio of the Value added (constant 2005 US$) of 1963 in Costa Rica to that in Indonesia?
Give a very brief answer. 0.17. What is the ratio of the Value added (constant 2005 US$) in 1960 in Guatemala to that in Honduras?
Your answer should be compact. 3.87. What is the ratio of the Value added (constant 2005 US$) in 1961 in Guatemala to that in Honduras?
Your answer should be very brief. 3.98. What is the ratio of the Value added (constant 2005 US$) in 1962 in Guatemala to that in Honduras?
Provide a short and direct response. 3.98. What is the ratio of the Value added (constant 2005 US$) of 1963 in Guatemala to that in Honduras?
Provide a succinct answer. 4.07. What is the ratio of the Value added (constant 2005 US$) in 1960 in Guatemala to that in India?
Keep it short and to the point. 0.09. What is the ratio of the Value added (constant 2005 US$) of 1961 in Guatemala to that in India?
Your answer should be very brief. 0.09. What is the ratio of the Value added (constant 2005 US$) in 1962 in Guatemala to that in India?
Offer a terse response. 0.09. What is the ratio of the Value added (constant 2005 US$) in 1963 in Guatemala to that in India?
Offer a terse response. 0.09. What is the ratio of the Value added (constant 2005 US$) of 1960 in Guatemala to that in Indonesia?
Provide a short and direct response. 0.31. What is the ratio of the Value added (constant 2005 US$) in 1961 in Guatemala to that in Indonesia?
Your answer should be very brief. 0.29. What is the ratio of the Value added (constant 2005 US$) in 1962 in Guatemala to that in Indonesia?
Ensure brevity in your answer.  0.3. What is the ratio of the Value added (constant 2005 US$) in 1963 in Guatemala to that in Indonesia?
Ensure brevity in your answer.  0.32. What is the ratio of the Value added (constant 2005 US$) in 1960 in Honduras to that in India?
Provide a succinct answer. 0.02. What is the ratio of the Value added (constant 2005 US$) in 1961 in Honduras to that in India?
Keep it short and to the point. 0.02. What is the ratio of the Value added (constant 2005 US$) of 1962 in Honduras to that in India?
Keep it short and to the point. 0.02. What is the ratio of the Value added (constant 2005 US$) in 1963 in Honduras to that in India?
Give a very brief answer. 0.02. What is the ratio of the Value added (constant 2005 US$) of 1960 in Honduras to that in Indonesia?
Keep it short and to the point. 0.08. What is the ratio of the Value added (constant 2005 US$) in 1961 in Honduras to that in Indonesia?
Make the answer very short. 0.07. What is the ratio of the Value added (constant 2005 US$) in 1962 in Honduras to that in Indonesia?
Your response must be concise. 0.07. What is the ratio of the Value added (constant 2005 US$) of 1963 in Honduras to that in Indonesia?
Keep it short and to the point. 0.08. What is the ratio of the Value added (constant 2005 US$) of 1960 in India to that in Indonesia?
Your response must be concise. 3.47. What is the ratio of the Value added (constant 2005 US$) of 1961 in India to that in Indonesia?
Ensure brevity in your answer.  3.32. What is the ratio of the Value added (constant 2005 US$) of 1962 in India to that in Indonesia?
Your answer should be very brief. 3.44. What is the ratio of the Value added (constant 2005 US$) in 1963 in India to that in Indonesia?
Keep it short and to the point. 3.61. What is the difference between the highest and the second highest Value added (constant 2005 US$) of 1960?
Keep it short and to the point. 2.19e+1. What is the difference between the highest and the second highest Value added (constant 2005 US$) in 1961?
Your answer should be very brief. 2.26e+1. What is the difference between the highest and the second highest Value added (constant 2005 US$) in 1962?
Give a very brief answer. 2.41e+1. What is the difference between the highest and the second highest Value added (constant 2005 US$) in 1963?
Ensure brevity in your answer.  2.60e+1. What is the difference between the highest and the lowest Value added (constant 2005 US$) of 1960?
Offer a terse response. 3.05e+1. What is the difference between the highest and the lowest Value added (constant 2005 US$) of 1961?
Give a very brief answer. 3.21e+1. What is the difference between the highest and the lowest Value added (constant 2005 US$) of 1962?
Provide a succinct answer. 3.36e+1. What is the difference between the highest and the lowest Value added (constant 2005 US$) in 1963?
Provide a succinct answer. 3.55e+1. 